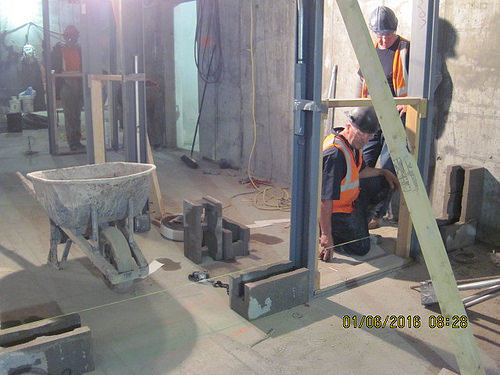<image>
Is there a helmet on the man? No. The helmet is not positioned on the man. They may be near each other, but the helmet is not supported by or resting on top of the man. 